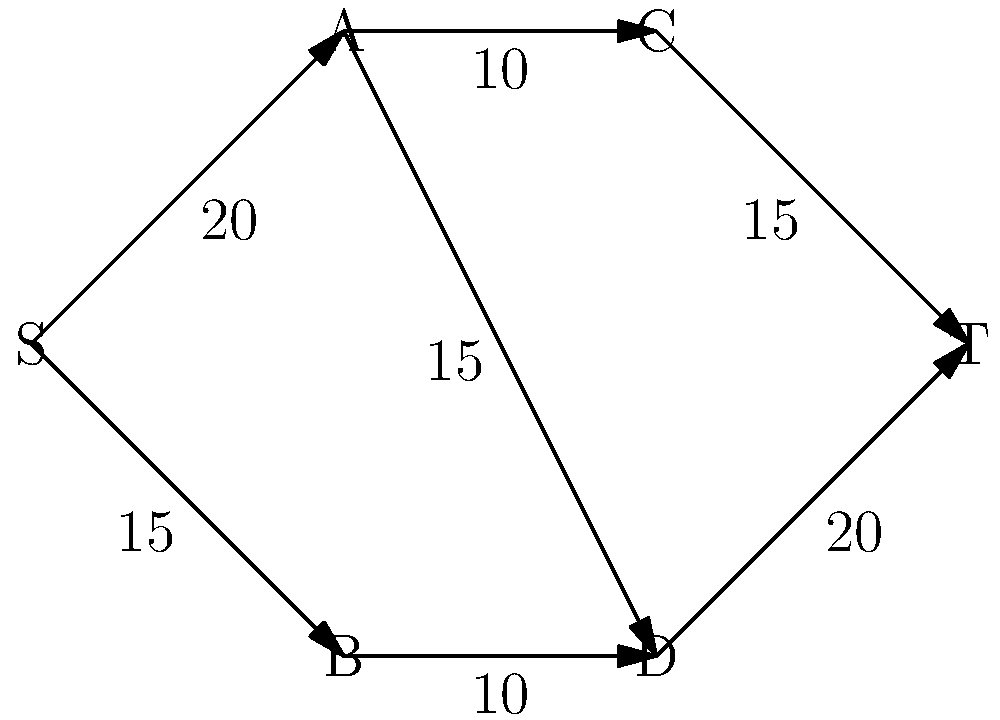You're planning a barbecue event and want to maximize the flow of customers through different stations. The network flow graph above represents the layout of your event space, where S is the entrance, T is the exit, and A, B, C, and D are different barbecue stations. The numbers on the edges represent the maximum number of customers that can move between stations per minute. What is the maximum flow of customers from entrance to exit per minute? To solve this problem, we'll use the Ford-Fulkerson algorithm to find the maximum flow:

1. Start with zero flow on all edges.

2. Find an augmenting path from S to T:
   Path 1: S → A → C → T (min capacity: 10)
   Increase flow by 10
   Residual graph: S→A: 10, A→C: 0, C→T: 5

3. Find another augmenting path:
   Path 2: S → B → D → T (min capacity: 10)
   Increase flow by 10
   Residual graph: S→B: 5, B→D: 0, D→T: 10

4. Find another augmenting path:
   Path 3: S → A → D → T (min capacity: 5)
   Increase flow by 5
   Residual graph: S→A: 5, A→D: 10, D→T: 5

5. Find another augmenting path:
   Path 4: S → A → D → T (min capacity: 5)
   Increase flow by 5
   Residual graph: S→A: 0, A→D: 5, D→T: 0

6. No more augmenting paths exist.

The maximum flow is the sum of all flow increases:
10 + 10 + 5 + 5 = 30 customers per minute.
Answer: 30 customers per minute 